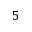Convert formula to latex. <formula><loc_0><loc_0><loc_500><loc_500>5</formula> 